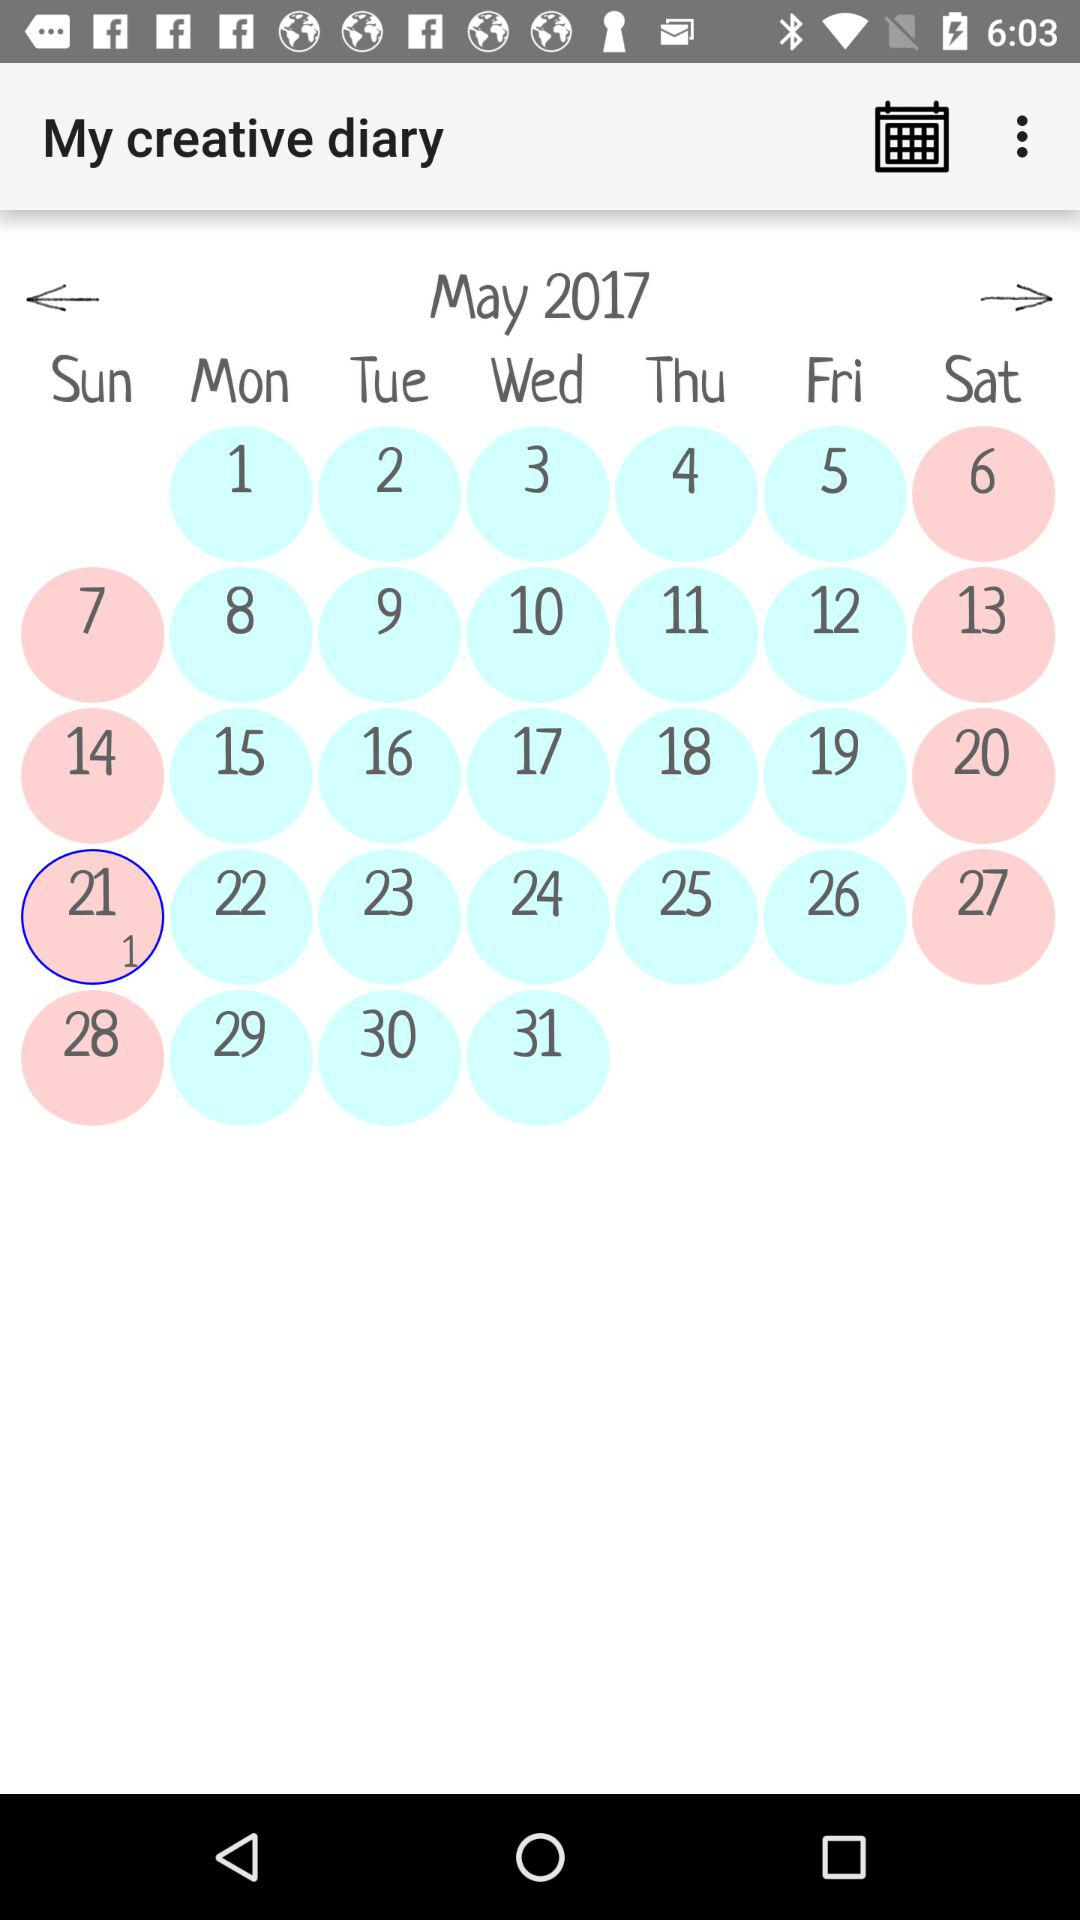Which date is selected? The selected date is Sunday, May 21, 2017. 